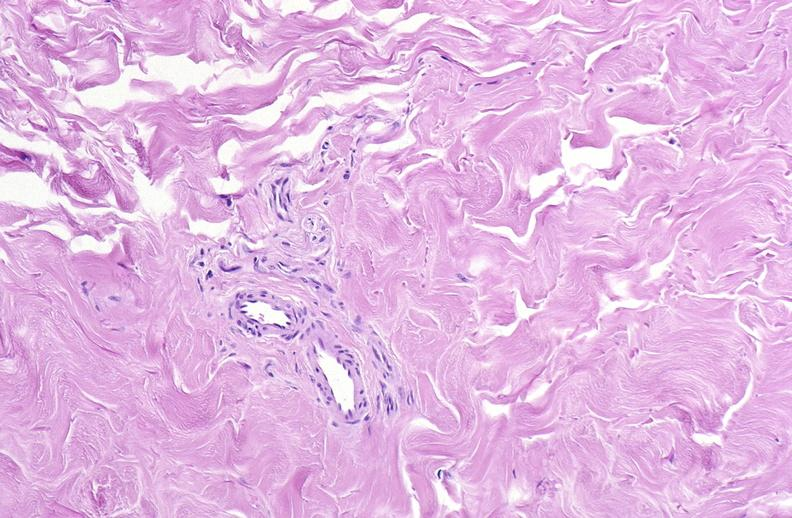where is this?
Answer the question using a single word or phrase. Skin 